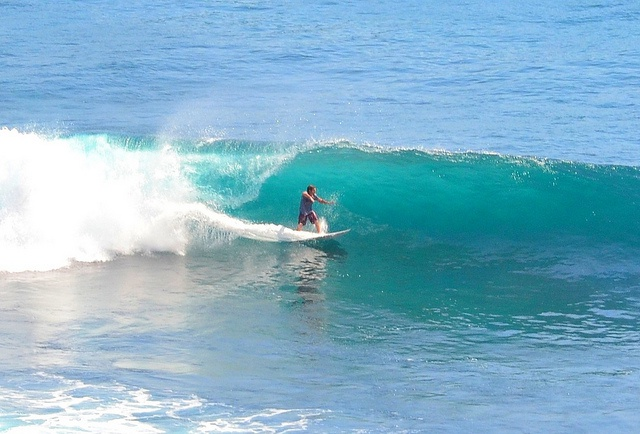Describe the objects in this image and their specific colors. I can see people in lightblue, gray, darkgray, blue, and teal tones and surfboard in lightblue, white, darkgray, and teal tones in this image. 